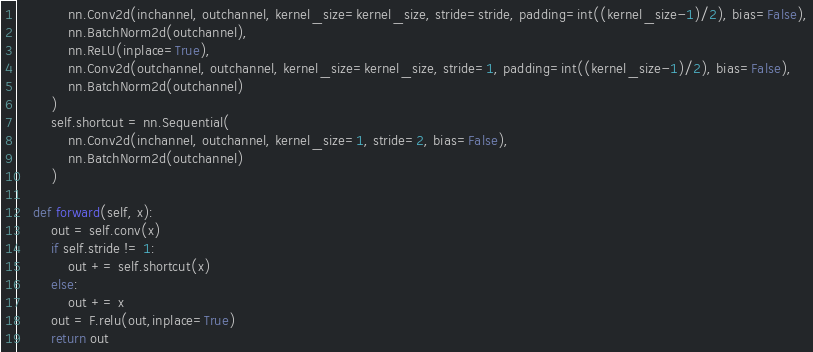<code> <loc_0><loc_0><loc_500><loc_500><_Python_>            nn.Conv2d(inchannel, outchannel, kernel_size=kernel_size, stride=stride, padding=int((kernel_size-1)/2), bias=False),
            nn.BatchNorm2d(outchannel),
            nn.ReLU(inplace=True),
            nn.Conv2d(outchannel, outchannel, kernel_size=kernel_size, stride=1, padding=int((kernel_size-1)/2), bias=False),
            nn.BatchNorm2d(outchannel)
        )
        self.shortcut = nn.Sequential(
            nn.Conv2d(inchannel, outchannel, kernel_size=1, stride=2, bias=False),
            nn.BatchNorm2d(outchannel)
        )

    def forward(self, x):
        out = self.conv(x)
        if self.stride != 1:
            out += self.shortcut(x)
        else:
            out += x
        out = F.relu(out,inplace=True)
        return out</code> 